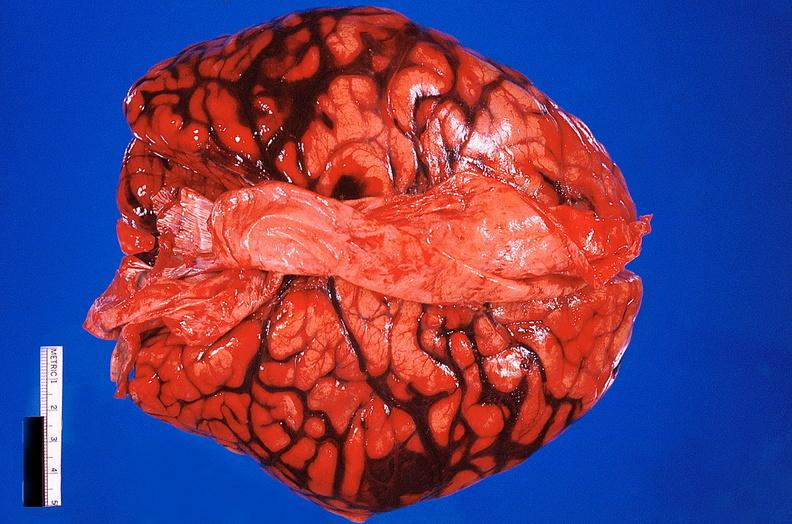s nervous present?
Answer the question using a single word or phrase. Yes 